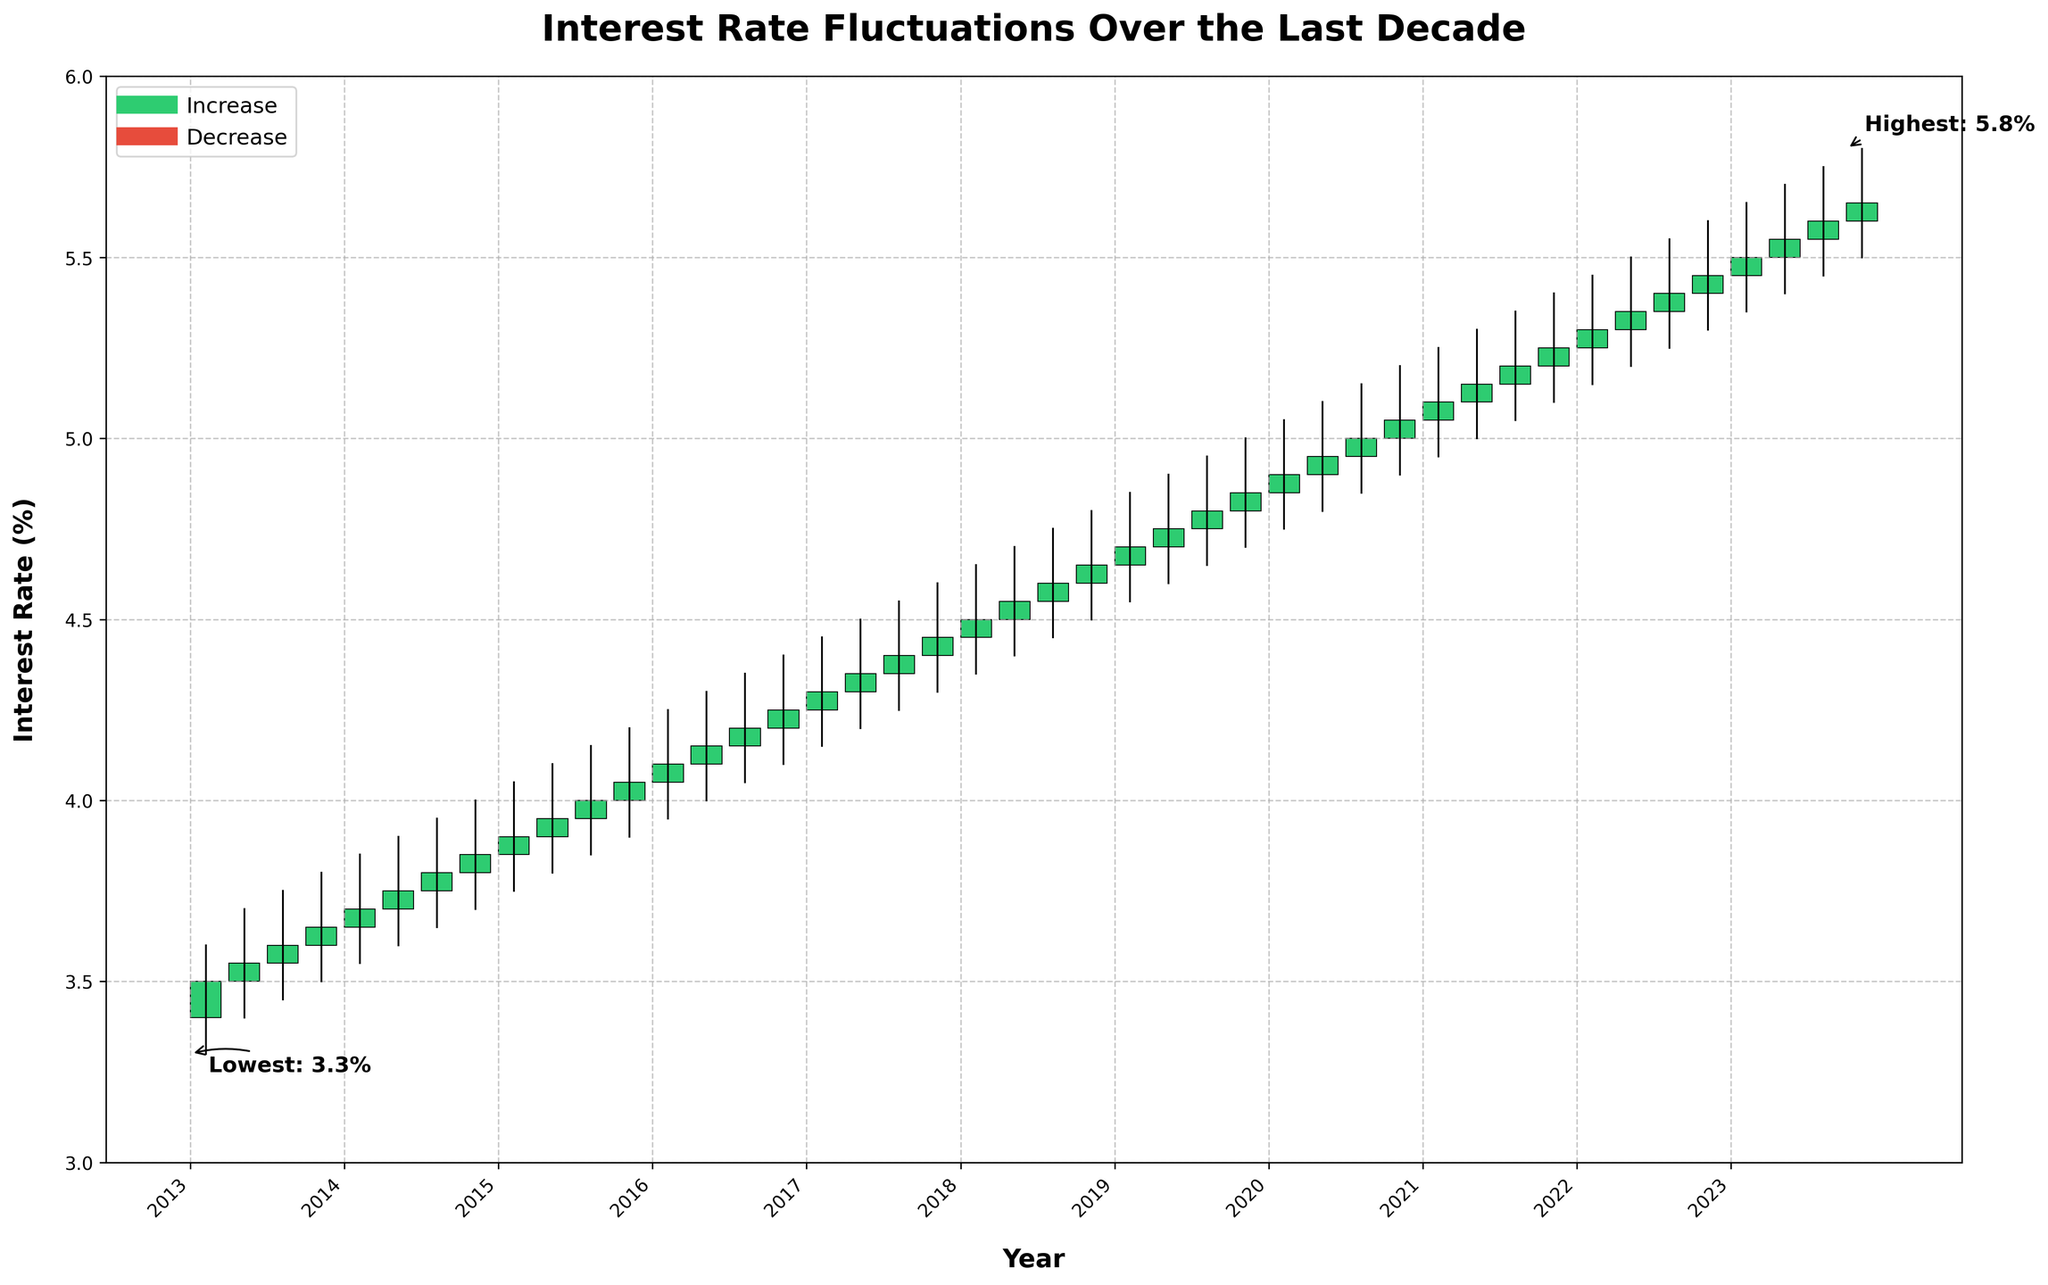What's the title of the chart? The title is usually located at the top of the chart and gives a quick overview of what the chart depicts. In this case, the title is centered at the top of the figure.
Answer: Interest Rate Fluctuations Over the Last Decade What color represents an increase in the interest rate? The color that represents an increase in the interest rate can be identified from the candlesticks in the chart. The legend also helps clarify this.
Answer: Green Which year had the highest interest rate and what was the rate? To find the highest interest rate, look for the point with the highest "High" value in the chart. It is also annotated on the chart for clarification.
Answer: 2020, 5.20% Which year had the lowest interest rate and what was the rate? To find the lowest interest rate, look for the point with the lowest "Low" value in the chart. This is also annotated on the chart for clarification.
Answer: 2013, 3.30% How many downward trends (red candlesticks) are there in the chart? By counting the number of red candlesticks in the chart, we can determine the number of downward trends in the interest rates.
Answer: 7 What was the average closing interest rate in 2016? Identify the closing rates for each quarter of 2016, sum them up, and then divide by the number of quarters. The closing rates are 4.10, 4.15, 4.20, and 4.25. The average is (4.10 + 4.15 + 4.20 + 4.25) / 4.
Answer: 4.18 Which year had the most stable interest rates? Compare the difference between the highest and lowest values within each year. The smallest range indicates the most stability.
Answer: 2014 How did the interest rate change from the first to the last quarter of 2018? Compare the "Open" value of the first quarter to the "Close" value of the last quarter of the year 2018. The "Open" value in 2018 Q1 is 4.45 and the "Close" value in 2018 Q4 is 4.65.
Answer: Increased by 0.20 Between 2017 and 2019, during which quarter was the highest closing rate observed? Identify the highest "Close" value between 2017 and 2019 by examining all the quarters within these years. The highest "Close" value is observed in Q1 of 2019.
Answer: Q1 2019, 4.85 What was the overall trend of interest rates from 2013 to 2023, and what might this indicate for our mortgage brokerage? Observe the general movement of interest rates from 2013 to 2023. The interest rates have a consistent upward trend, indicated by a general increase from 2013 to 2023. This may suggest that obtaining favorable mortgage rates could become more challenging over time, and strategies should be adapted accordingly.
Answer: Upward trend 